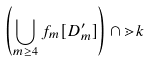<formula> <loc_0><loc_0><loc_500><loc_500>\left ( \bigcup _ { m \geq 4 } f _ { m } [ D ^ { \prime } _ { m } ] \right ) \cap \mathbb { m } { k }</formula> 